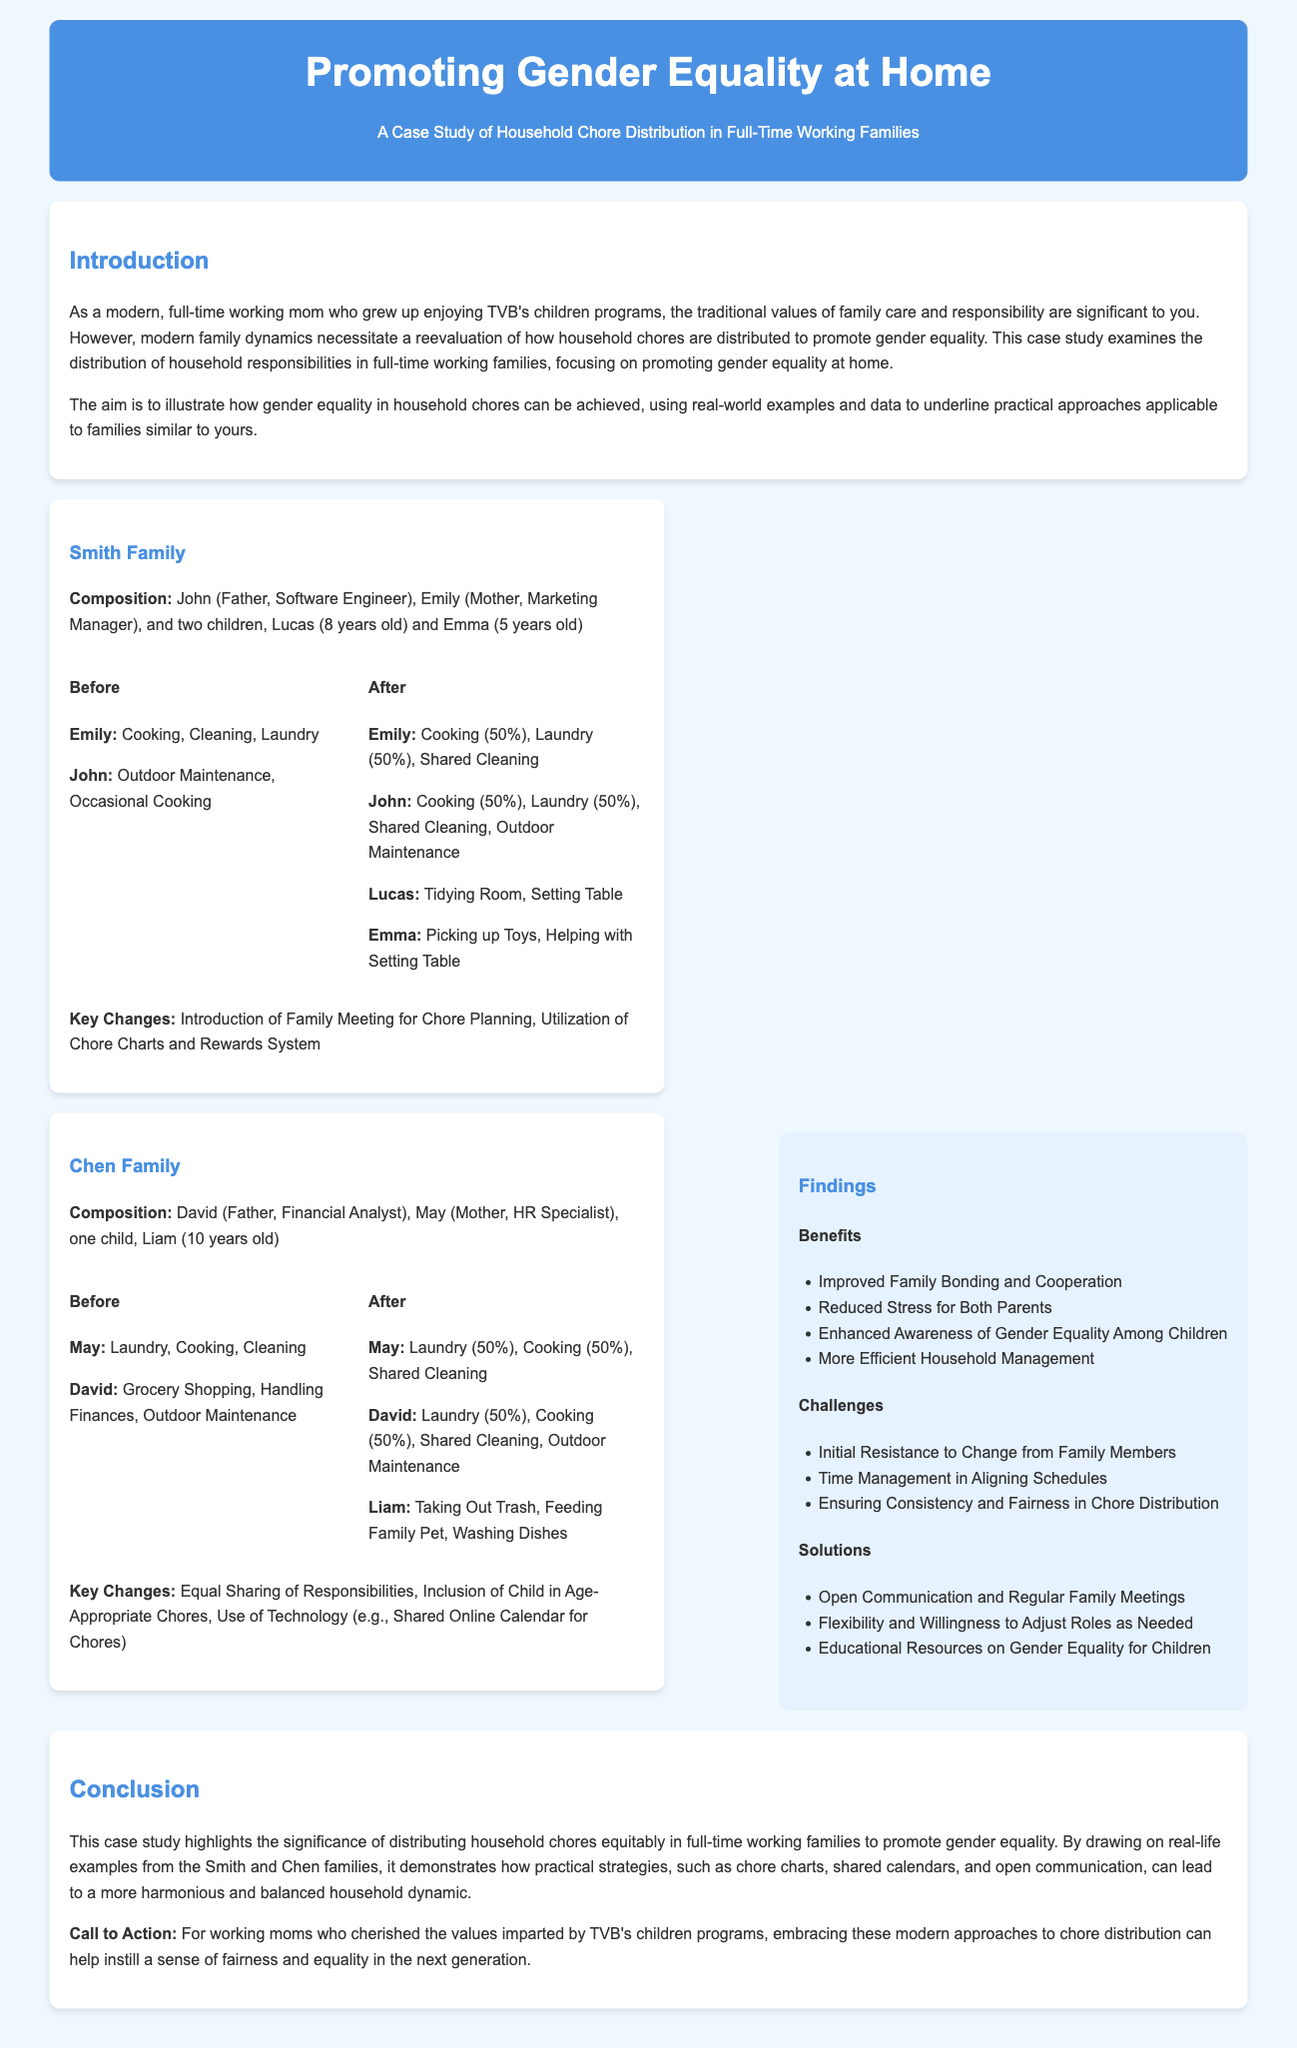What is the profession of Emily? Emily is identified as a Marketing Manager in the document.
Answer: Marketing Manager How many children do the Smith family have? The Smith family has two children: Lucas and Emma.
Answer: Two What did the Smith family introduce for chore planning? The document states that the Smith family introduced a Family Meeting for Chore Planning.
Answer: Family Meeting What technology did the Chen family use for chore management? The document mentions the use of a Shared Online Calendar for Chores by the Chen family.
Answer: Shared Online Calendar What percentage of cooking responsibility does Emily have after the changes? After the changes, Emily shares cooking responsibility at 50%.
Answer: 50% What is one benefit of chore distribution mentioned in the findings? One benefit listed is Improved Family Bonding and Cooperation.
Answer: Improved Family Bonding What is a challenge faced by families when changing chore distribution? The document suggests Initial Resistance to Change from Family Members as a challenge.
Answer: Initial Resistance Which age-appropriate chore is assigned to Liam? Liam's assigned chore mentioned is Taking Out Trash.
Answer: Taking Out Trash 